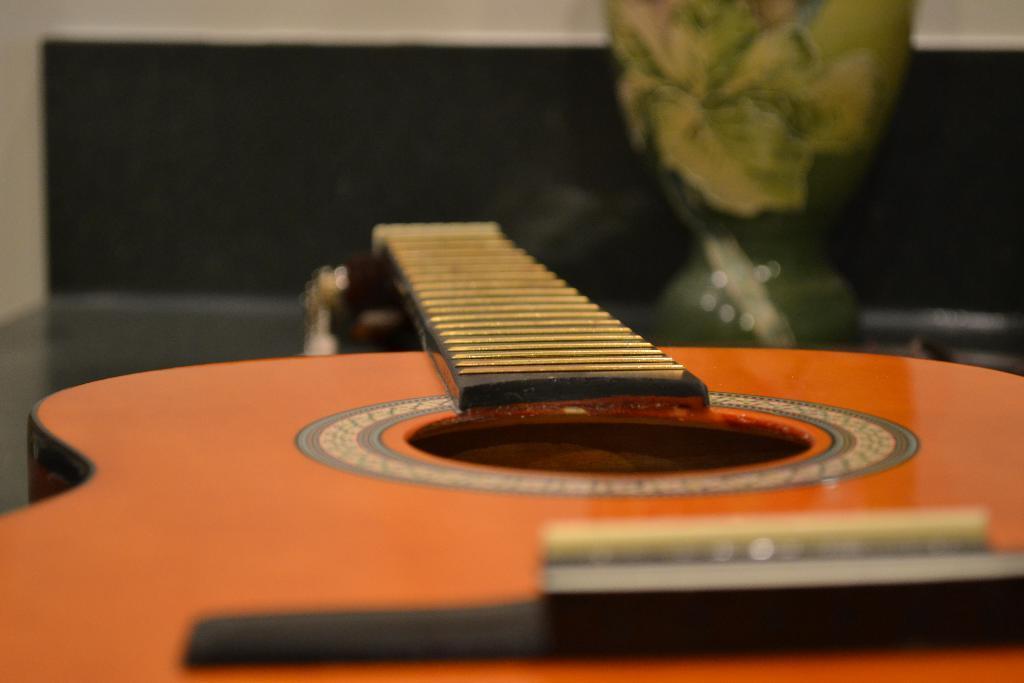Describe this image in one or two sentences. In this picture we can see a guitar on the table, and some objects on it. 